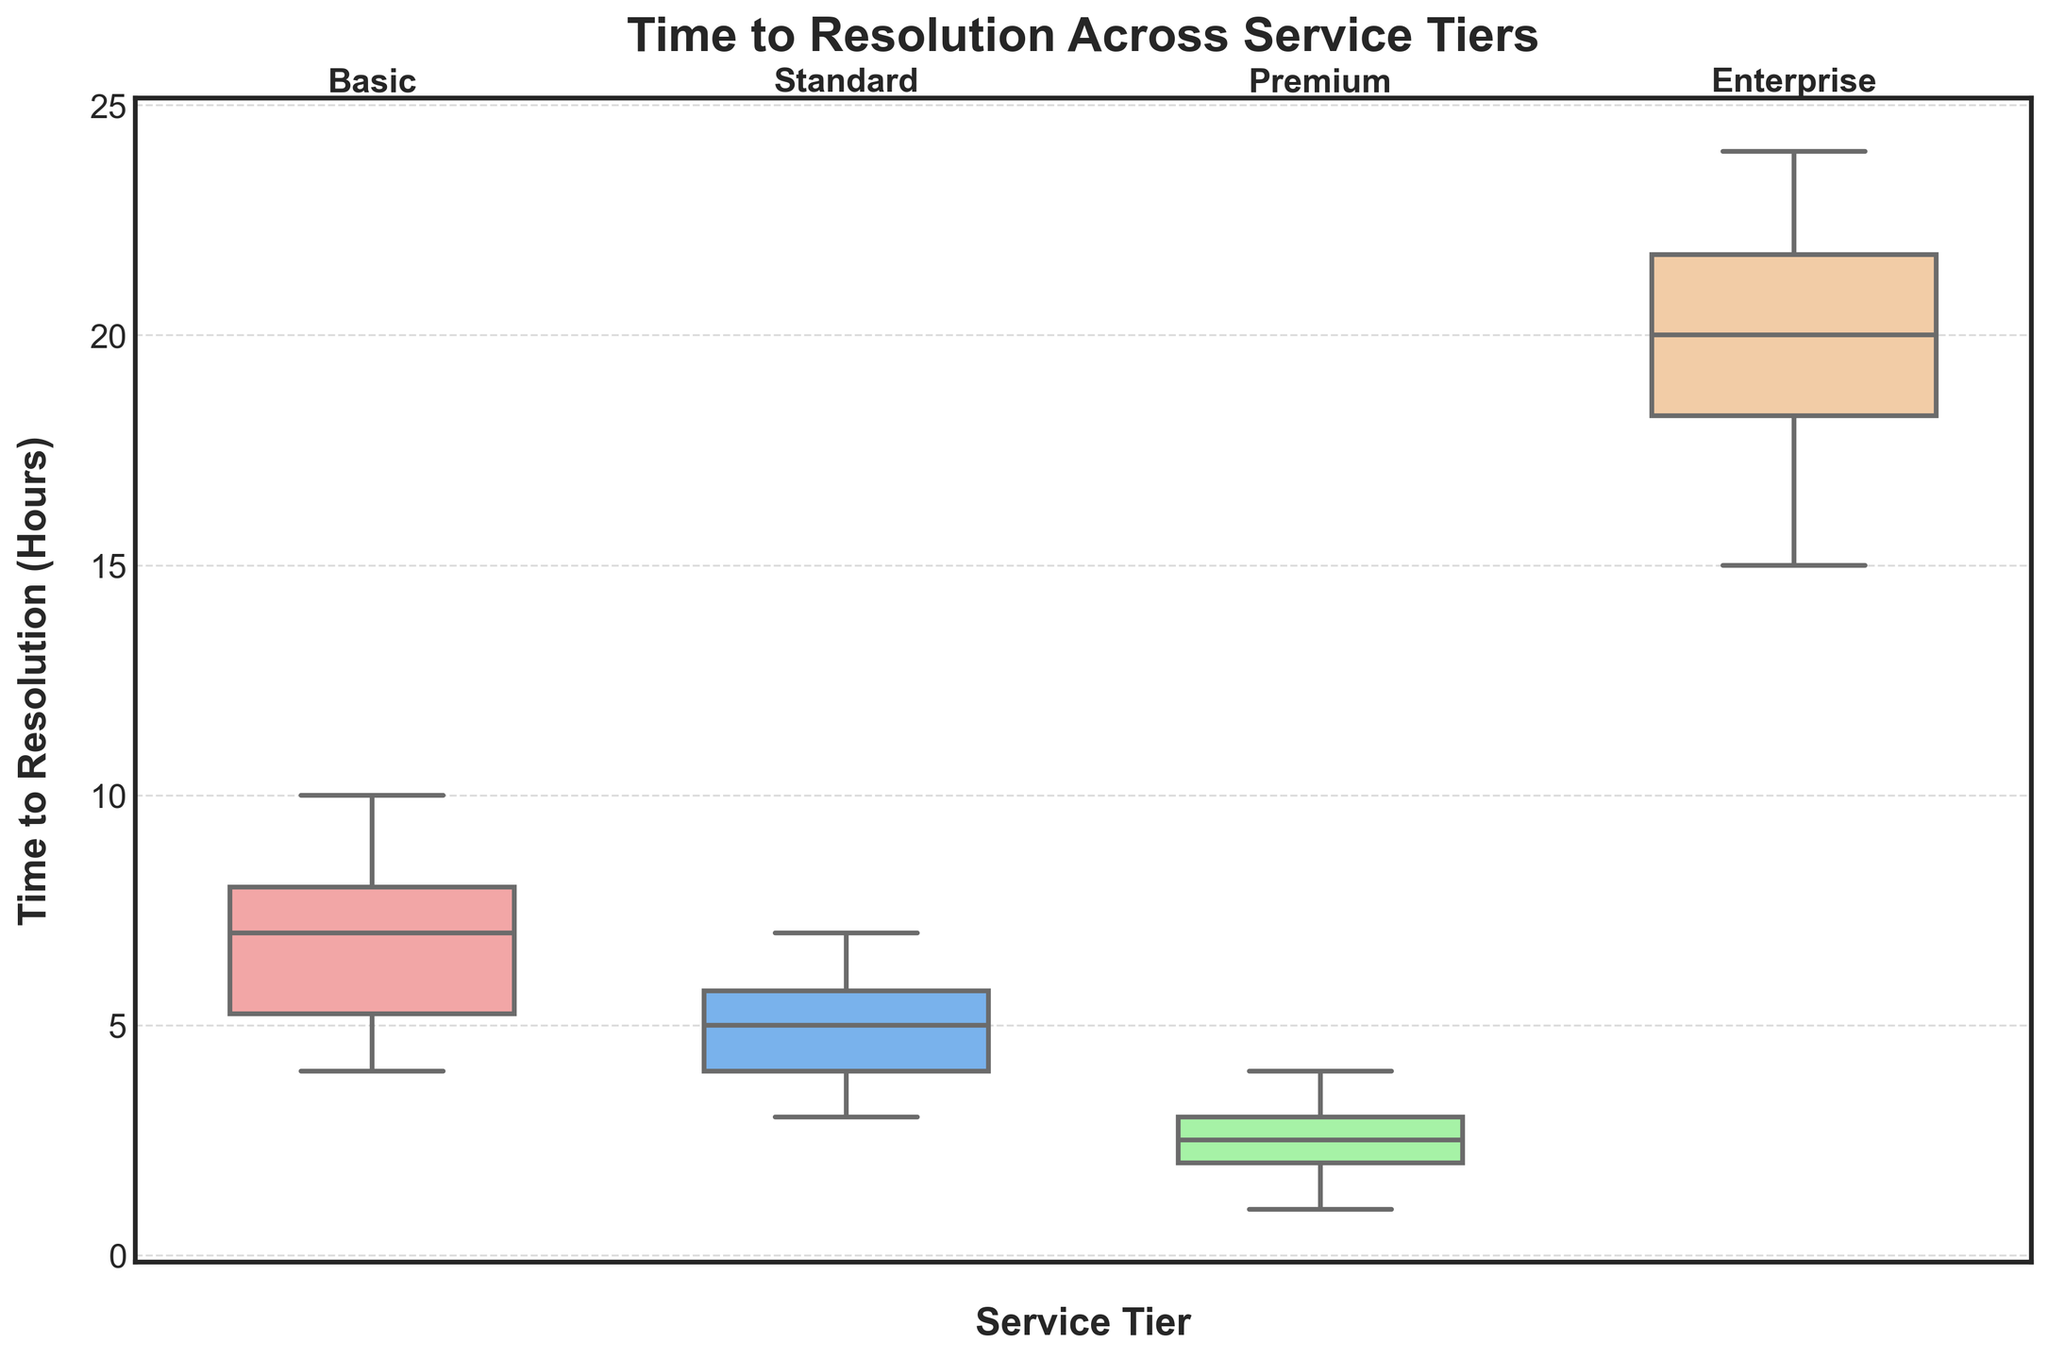What is the title of the plot? The title of the plot is located at the top and highlights the main subject of the figure. It reads "Time to Resolution Across Service Tiers."
Answer: Time to Resolution Across Service Tiers What is the median Time to Resolution for the Premium tier? The median is represented by the line inside the box of the Premium tier's box plot.
Answer: 2.5 hours How does the interquartile range (IQR) compare between the Basic and Standard tiers? The IQR is the range between the 25th and 75th percentiles, indicated by the lengths of the boxes. By comparing the lengths of the boxes for Basic and Standard, it can be seen that the IQR for Basic is larger than that for Standard.
Answer: Basic has a larger IQR than Standard Which service tier has the shortest time to resolution? The minimum value at the bottom whisker represents the shortest time to resolution, visible for the Premium tier.
Answer: Premium Among all service tiers, which has the highest range of Time to Resolution? The range is the difference between the maximum and minimum values, represented by the ends of the whiskers. The Enterprise tier has the highest whisker values.
Answer: Enterprise Which tier has the highest median Time to Resolution and by how much? By comparing the medians indicated by the lines within the boxes, Enterprise has the highest median Time to Resolution compared to the others.
Answer: Enterprise, by 19 hours What is the time range covered by the whiskers for the Basic tier? The whiskers extend from the minimum to the maximum time to resolution. For Basic, this range can be identified by locating the ends of the whiskers.
Answer: 4 to 10 hours Between Standard and Premium tiers, which has a more consistent (less spread out) Time to Resolution? Consistency can be observed by the spread of the data. The Premium tier has a more compact box and shorter whiskers than the Standard tier.
Answer: Premium In which tier does the median Time to Resolution fall within the 1st quartile (Q1) of the Enterprise tier? The median Time to Resolution for other tiers must be below the 25th percentile of the Enterprise tier (represented by the bottom of Enterprise's box). Comparing these values shows that the Premium tier's median falls within Enterprise’s first quartile.
Answer: Premium How do the whisker lengths compare between the Standard and Premium tiers? Whisker lengths indicate the spread of the data. The Standard tier has longer whiskers compared to the Premium tier.
Answer: Standard has longer whiskers 